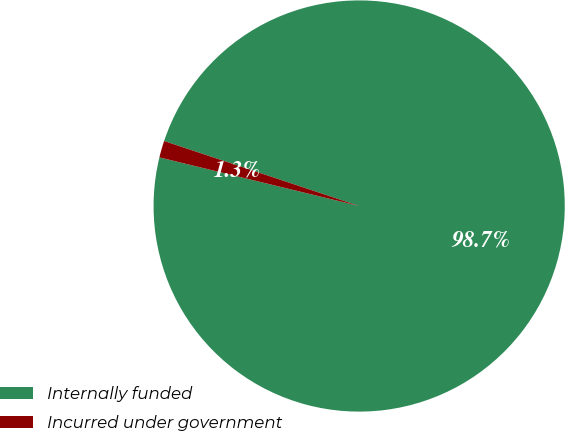Convert chart to OTSL. <chart><loc_0><loc_0><loc_500><loc_500><pie_chart><fcel>Internally funded<fcel>Incurred under government<nl><fcel>98.68%<fcel>1.32%<nl></chart> 